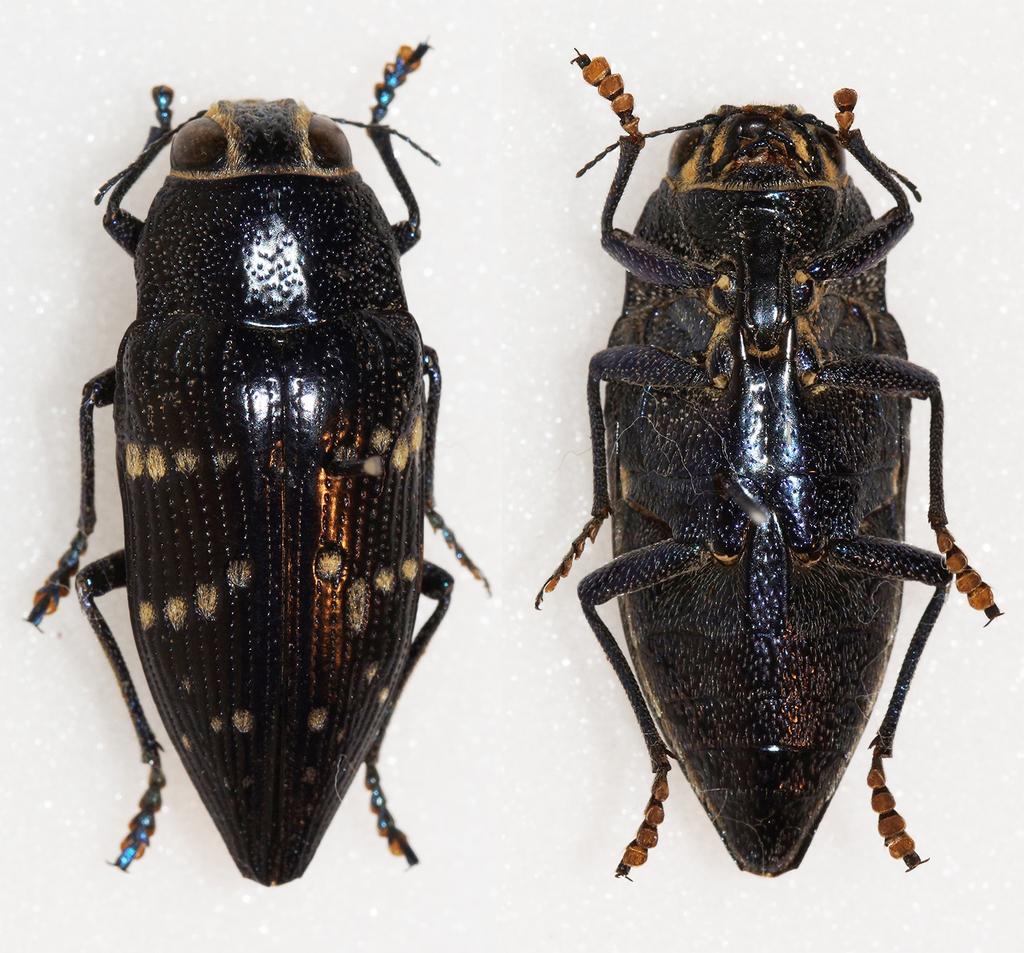How many insects are present in the image? There are two insects in the image. What is the background or surface on which the insects are located? The insects are on a white surface. What type of substance is the insects using to communicate with each other in the image? There is no indication in the image that the insects are using any substance to communicate with each other. 